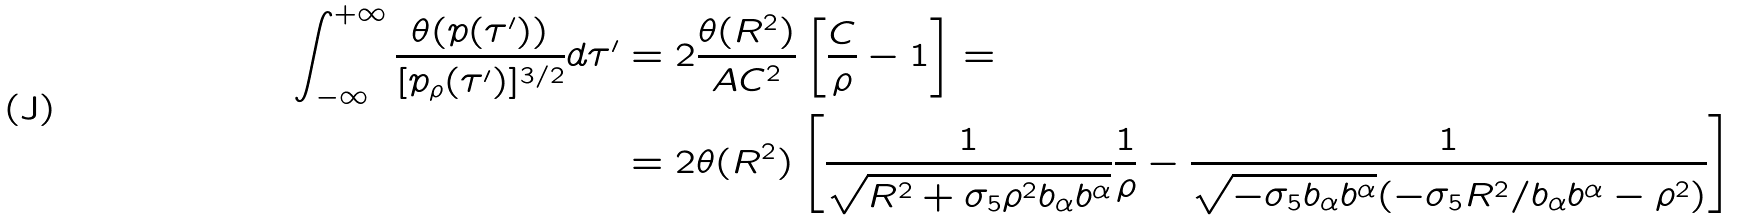<formula> <loc_0><loc_0><loc_500><loc_500>\int _ { - \infty } ^ { + \infty } \frac { \theta ( p ( \tau ^ { \prime } ) ) } { [ p _ { \rho } ( \tau ^ { \prime } ) ] ^ { 3 / 2 } } d \tau ^ { \prime } & = 2 \frac { \theta ( R ^ { 2 } ) } { A C ^ { 2 } } \left [ \frac { C } { \rho } - 1 \right ] = \\ & = 2 \theta ( R ^ { 2 } ) \left [ \frac { 1 } { \sqrt { R ^ { 2 } + \sigma _ { 5 } \rho ^ { 2 } b _ { \alpha } b ^ { \alpha } } } \frac { 1 } { \rho } - \frac { 1 } { \sqrt { - \sigma _ { 5 } b _ { \alpha } b ^ { \alpha } } ( - \sigma _ { 5 } R ^ { 2 } / b _ { \alpha } b ^ { \alpha } - \rho ^ { 2 } ) } \right ]</formula> 